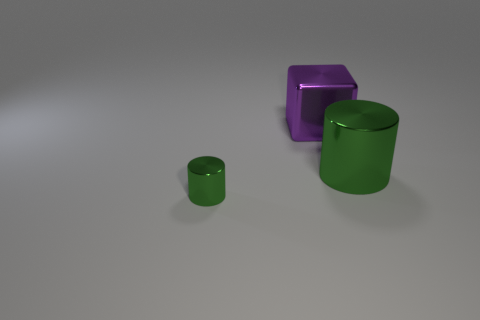Add 3 metallic cubes. How many objects exist? 6 Subtract all yellow cubes. How many yellow cylinders are left? 0 Subtract all tiny green cylinders. Subtract all purple objects. How many objects are left? 1 Add 3 metallic objects. How many metallic objects are left? 6 Add 1 tiny purple cubes. How many tiny purple cubes exist? 1 Subtract 0 red blocks. How many objects are left? 3 Subtract all cubes. How many objects are left? 2 Subtract all purple cylinders. Subtract all gray cubes. How many cylinders are left? 2 